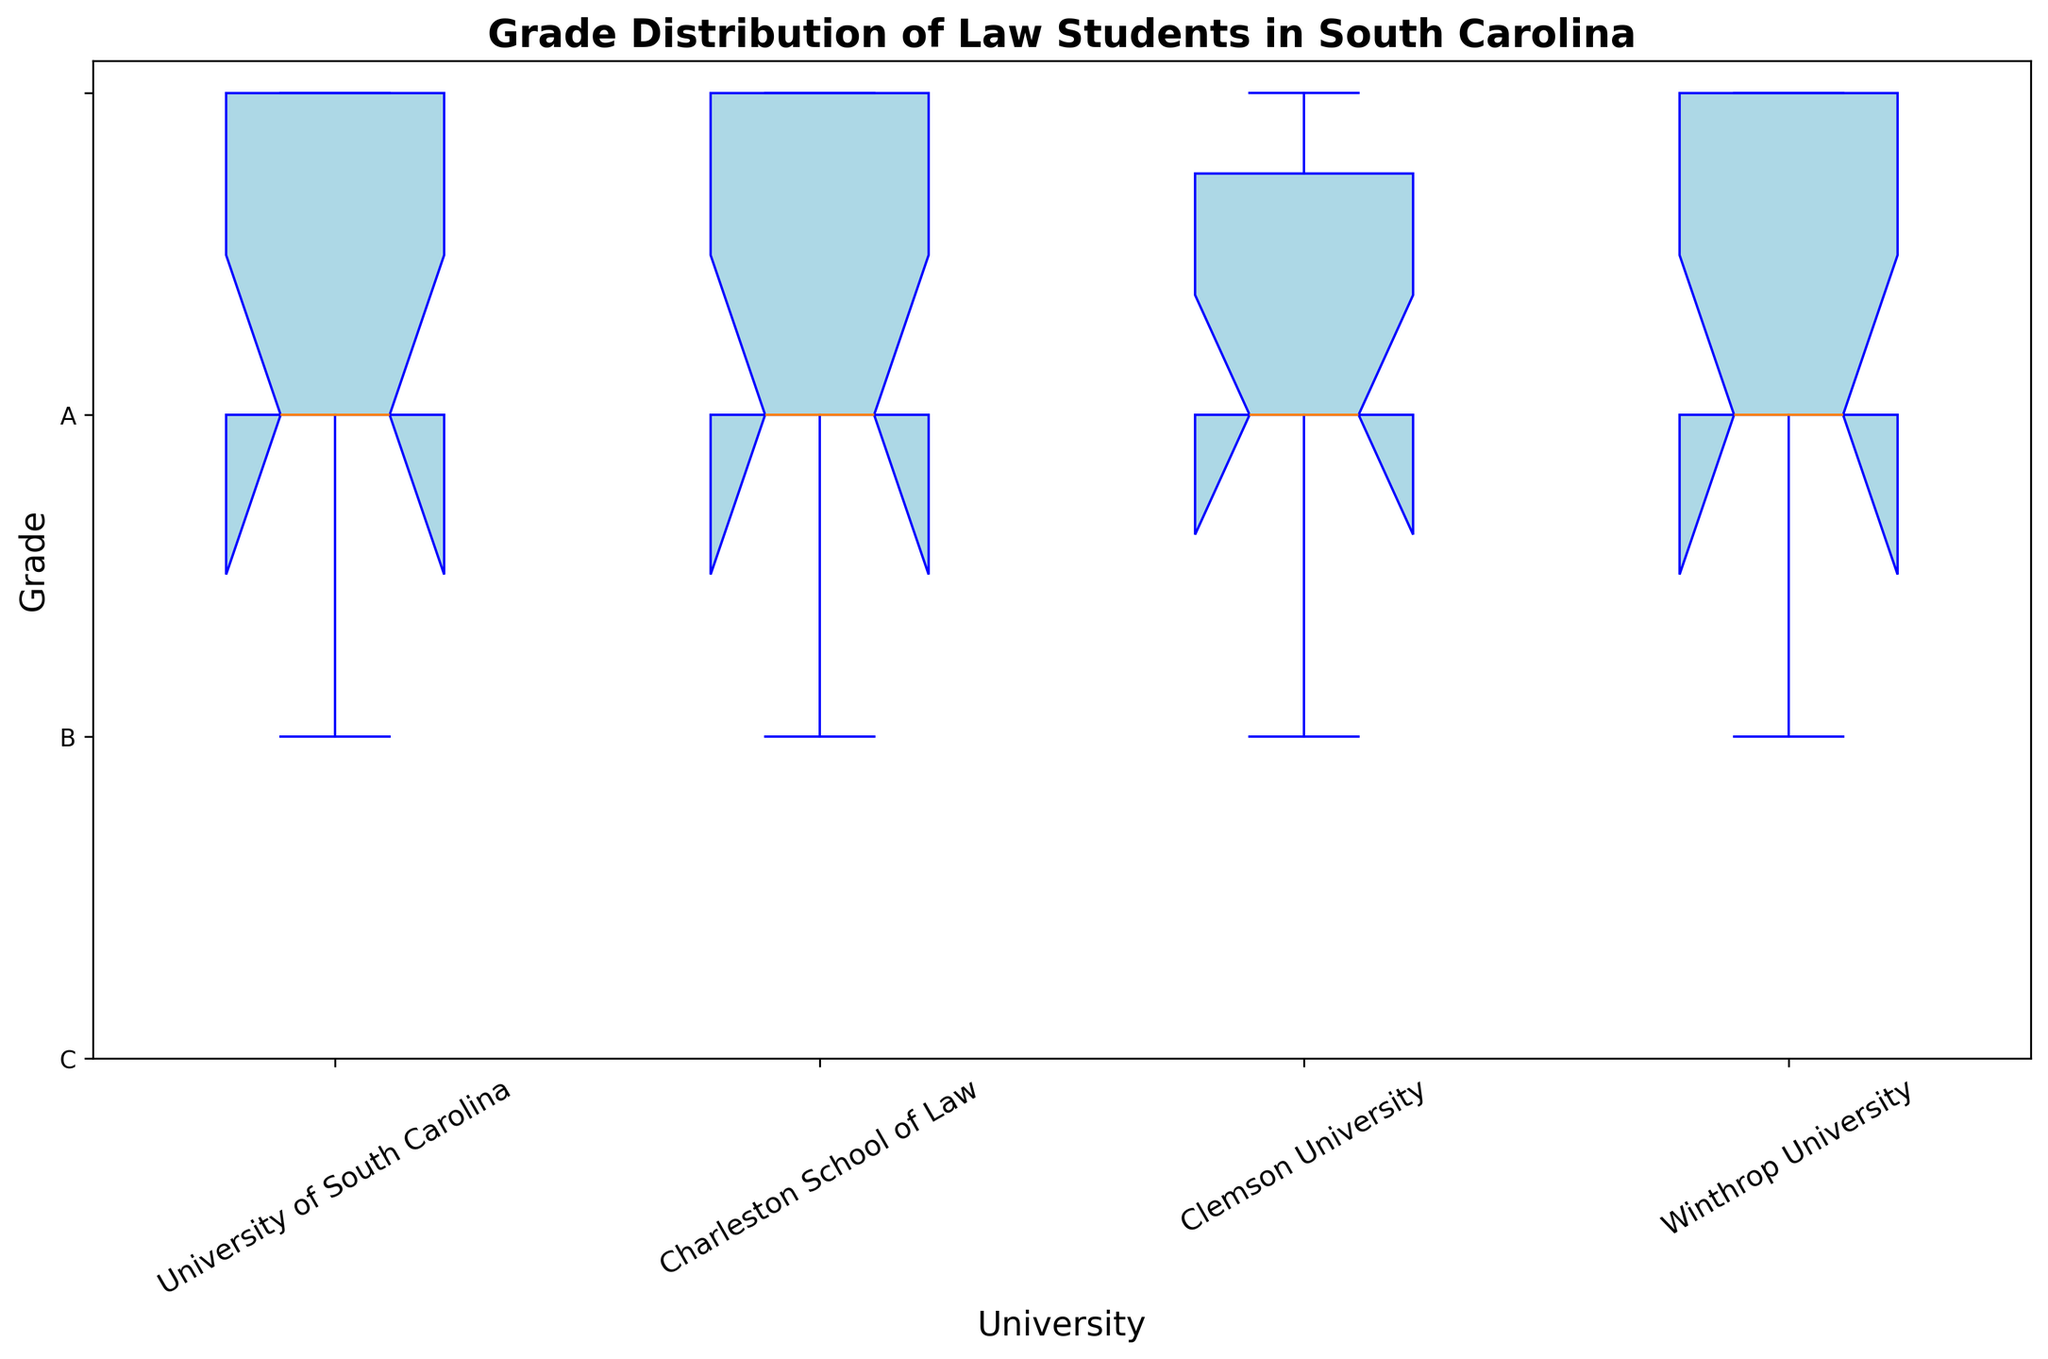Which university has the widest range of grades? To determine the university with the widest range of grades, observe the length of the boxes and whiskers for each university’s box plot. The university with the longest box and whiskers has the widest range.
Answer: Charleston School of Law Which university has the highest median grade? The median grade is represented by the line inside the box of each university's box plot. Identify which box plot has the highest line.
Answer: University of South Carolina Which university has the most outliers? Outliers in a box plot are shown as individual points outside the whiskers. Count the outliers for each university's box plot and identify the one with the most points.
Answer: Clemson University What is the median grade for the Charleston School of Law? The median grade for Charleston School of Law can be found by looking at the line inside the box of Charleston School of Law’s box plot.
Answer: B How do the whiskers of Winthrop University compare to those of Clemson University? Compare the length of the whiskers (the lines extending from the box) for both Winthrop University and Clemson University.
Answer: Winthrop's whiskers are shorter Which university has the lowest recorded grade? The lowest recorded grade is shown by the bottommost point of the whiskers in each box plot. Identify the university with this lowest point.
Answer: University of South Carolina Are there any universities without outliers? Check each box plot; if no points lie outside the whiskers, that university has no outliers.
Answer: University of South Carolina and Charleston School of Law 